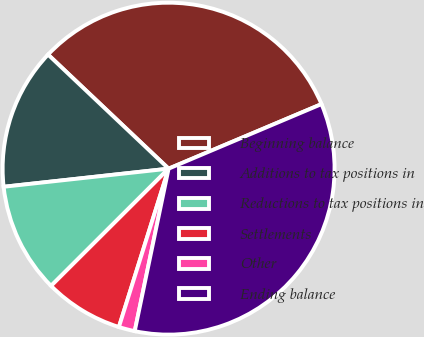Convert chart to OTSL. <chart><loc_0><loc_0><loc_500><loc_500><pie_chart><fcel>Beginning balance<fcel>Additions to tax positions in<fcel>Reductions to tax positions in<fcel>Settlements<fcel>Other<fcel>Ending balance<nl><fcel>31.58%<fcel>13.8%<fcel>10.74%<fcel>7.68%<fcel>1.57%<fcel>34.63%<nl></chart> 